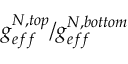<formula> <loc_0><loc_0><loc_500><loc_500>g _ { e f f } ^ { N , t o p } / g _ { e f f } ^ { N , b o t t o m }</formula> 